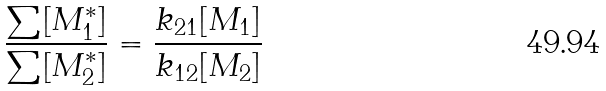Convert formula to latex. <formula><loc_0><loc_0><loc_500><loc_500>\frac { \sum [ M _ { 1 } ^ { * } ] } { \sum [ M _ { 2 } ^ { * } ] } = \frac { k _ { 2 1 } [ M _ { 1 } ] } { k _ { 1 2 } [ M _ { 2 } ] }</formula> 